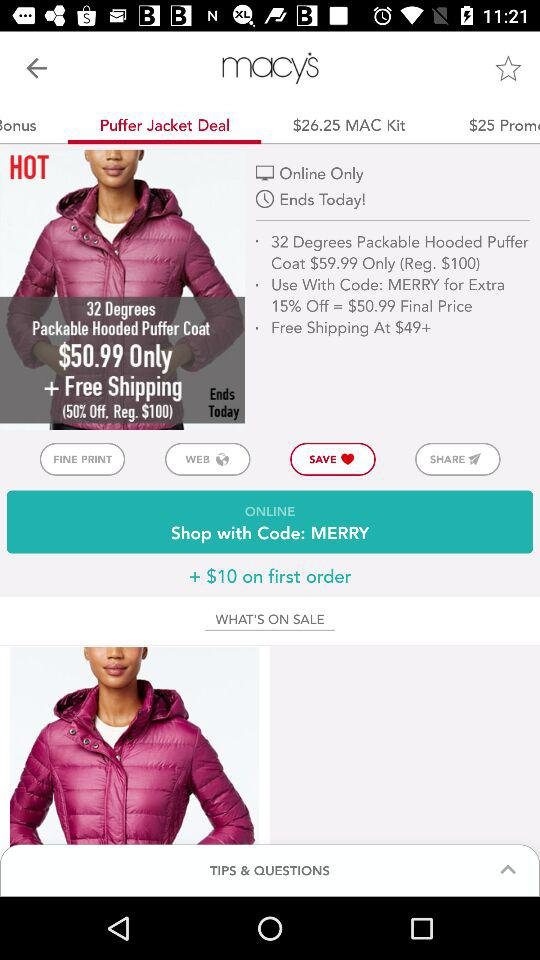Which option is selected in the "macy's" menu? The selected option is "Puffer Jacket Deal". 